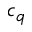Convert formula to latex. <formula><loc_0><loc_0><loc_500><loc_500>c _ { q }</formula> 